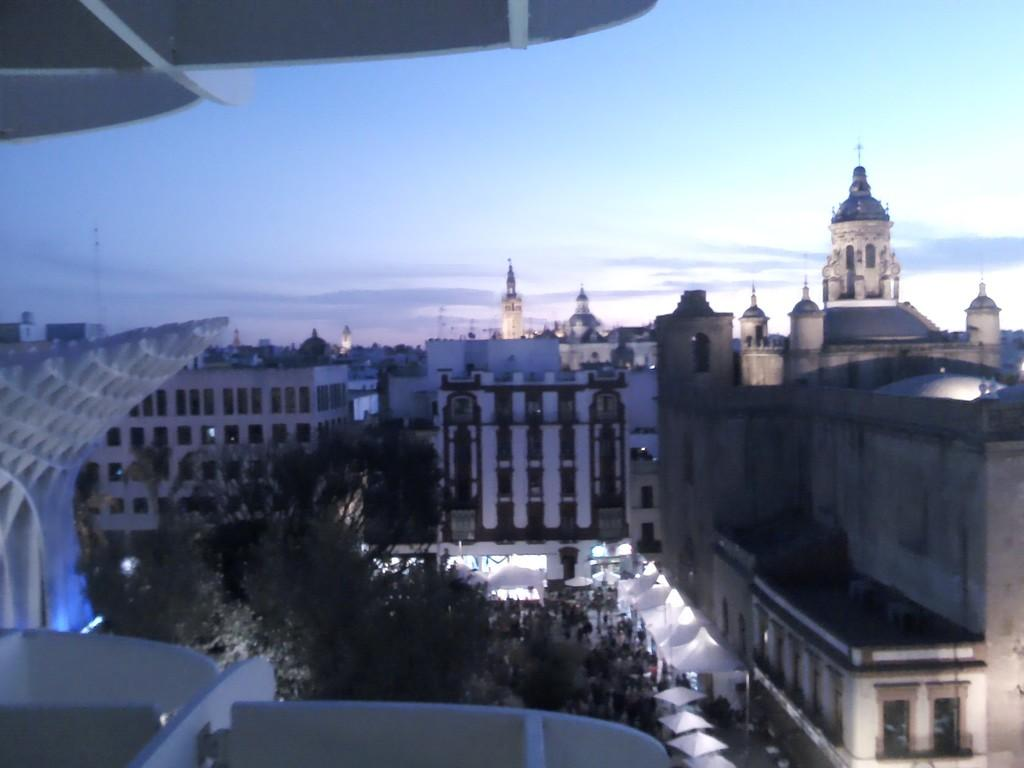What type of natural elements are present in the image? There are trees in the middle of the image. What type of man-made structures can be seen in the image? There are buildings in the image. What is the condition of the sky in the image? The sky is cloudy and visible at the top of the image. Who is the creator of the destruction visible in the image? There is no destruction visible in the image, only trees, buildings, and a cloudy sky. What type of button can be seen on the trees in the image? There are no buttons present on the trees in the image. 